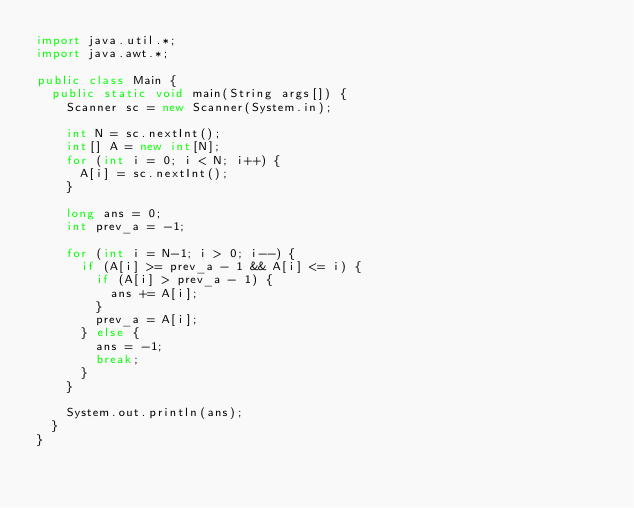Convert code to text. <code><loc_0><loc_0><loc_500><loc_500><_Java_>import java.util.*;
import java.awt.*;

public class Main {
  public static void main(String args[]) {
    Scanner sc = new Scanner(System.in);

    int N = sc.nextInt();
    int[] A = new int[N];
    for (int i = 0; i < N; i++) {
      A[i] = sc.nextInt();
    }

    long ans = 0;
    int prev_a = -1;

    for (int i = N-1; i > 0; i--) {
      if (A[i] >= prev_a - 1 && A[i] <= i) {
        if (A[i] > prev_a - 1) {
          ans += A[i];
        }
        prev_a = A[i];
      } else {
        ans = -1;
        break;
      }
    }

    System.out.println(ans);
  }
}
</code> 